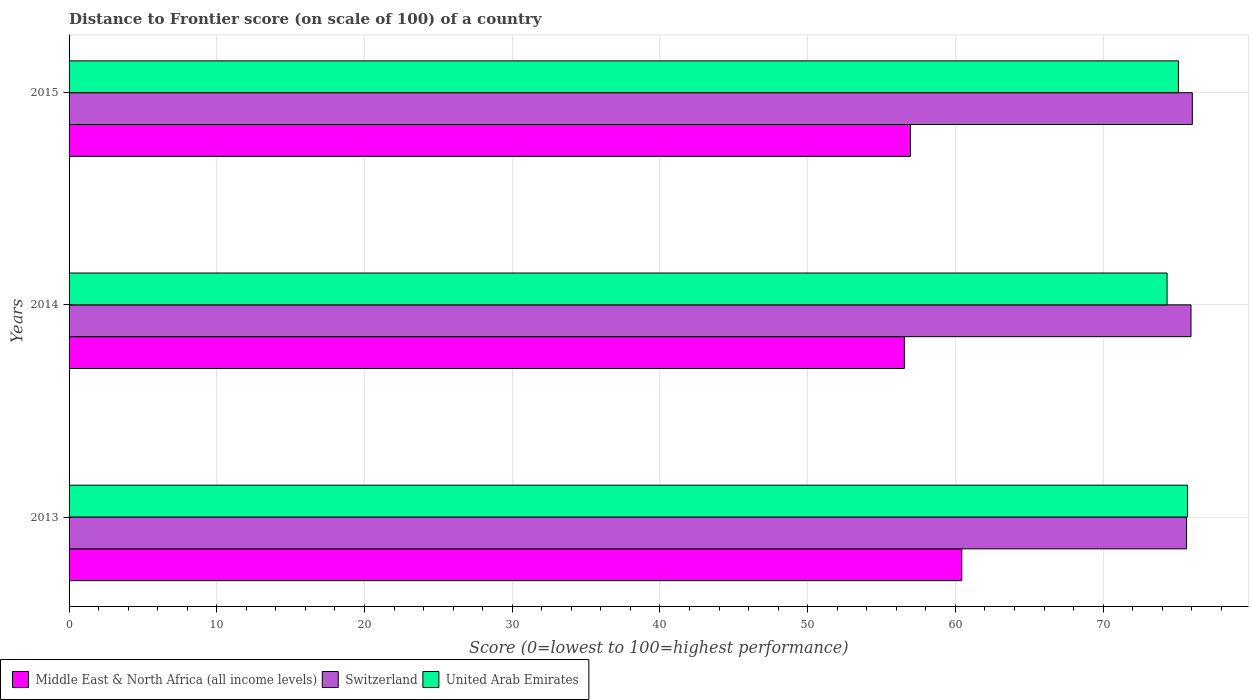How many bars are there on the 3rd tick from the bottom?
Offer a very short reply. 3. In how many cases, is the number of bars for a given year not equal to the number of legend labels?
Your answer should be very brief. 0. What is the distance to frontier score of in Middle East & North Africa (all income levels) in 2013?
Your response must be concise. 60.43. Across all years, what is the maximum distance to frontier score of in Middle East & North Africa (all income levels)?
Your answer should be compact. 60.43. Across all years, what is the minimum distance to frontier score of in United Arab Emirates?
Keep it short and to the point. 74.33. In which year was the distance to frontier score of in United Arab Emirates minimum?
Keep it short and to the point. 2014. What is the total distance to frontier score of in Middle East & North Africa (all income levels) in the graph?
Make the answer very short. 173.94. What is the difference between the distance to frontier score of in Middle East & North Africa (all income levels) in 2013 and that in 2014?
Your answer should be very brief. 3.89. What is the difference between the distance to frontier score of in United Arab Emirates in 2014 and the distance to frontier score of in Switzerland in 2015?
Offer a very short reply. -1.71. What is the average distance to frontier score of in Switzerland per year?
Offer a terse response. 75.88. In the year 2013, what is the difference between the distance to frontier score of in Middle East & North Africa (all income levels) and distance to frontier score of in Switzerland?
Offer a very short reply. -15.22. What is the ratio of the distance to frontier score of in United Arab Emirates in 2013 to that in 2015?
Your answer should be very brief. 1.01. Is the difference between the distance to frontier score of in Middle East & North Africa (all income levels) in 2013 and 2014 greater than the difference between the distance to frontier score of in Switzerland in 2013 and 2014?
Your response must be concise. Yes. What is the difference between the highest and the second highest distance to frontier score of in United Arab Emirates?
Your answer should be very brief. 0.61. What is the difference between the highest and the lowest distance to frontier score of in United Arab Emirates?
Offer a terse response. 1.38. What does the 3rd bar from the top in 2015 represents?
Ensure brevity in your answer.  Middle East & North Africa (all income levels). What does the 3rd bar from the bottom in 2014 represents?
Offer a terse response. United Arab Emirates. Is it the case that in every year, the sum of the distance to frontier score of in Middle East & North Africa (all income levels) and distance to frontier score of in Switzerland is greater than the distance to frontier score of in United Arab Emirates?
Provide a short and direct response. Yes. How many bars are there?
Keep it short and to the point. 9. Are all the bars in the graph horizontal?
Keep it short and to the point. Yes. How many years are there in the graph?
Offer a terse response. 3. Are the values on the major ticks of X-axis written in scientific E-notation?
Offer a very short reply. No. Where does the legend appear in the graph?
Your response must be concise. Bottom left. What is the title of the graph?
Provide a short and direct response. Distance to Frontier score (on scale of 100) of a country. Does "Bahrain" appear as one of the legend labels in the graph?
Ensure brevity in your answer.  No. What is the label or title of the X-axis?
Ensure brevity in your answer.  Score (0=lowest to 100=highest performance). What is the label or title of the Y-axis?
Your answer should be very brief. Years. What is the Score (0=lowest to 100=highest performance) in Middle East & North Africa (all income levels) in 2013?
Provide a short and direct response. 60.43. What is the Score (0=lowest to 100=highest performance) in Switzerland in 2013?
Provide a short and direct response. 75.65. What is the Score (0=lowest to 100=highest performance) in United Arab Emirates in 2013?
Give a very brief answer. 75.71. What is the Score (0=lowest to 100=highest performance) in Middle East & North Africa (all income levels) in 2014?
Your answer should be compact. 56.54. What is the Score (0=lowest to 100=highest performance) of Switzerland in 2014?
Keep it short and to the point. 75.95. What is the Score (0=lowest to 100=highest performance) of United Arab Emirates in 2014?
Offer a very short reply. 74.33. What is the Score (0=lowest to 100=highest performance) of Middle East & North Africa (all income levels) in 2015?
Ensure brevity in your answer.  56.96. What is the Score (0=lowest to 100=highest performance) in Switzerland in 2015?
Keep it short and to the point. 76.04. What is the Score (0=lowest to 100=highest performance) in United Arab Emirates in 2015?
Give a very brief answer. 75.1. Across all years, what is the maximum Score (0=lowest to 100=highest performance) in Middle East & North Africa (all income levels)?
Your answer should be compact. 60.43. Across all years, what is the maximum Score (0=lowest to 100=highest performance) of Switzerland?
Provide a succinct answer. 76.04. Across all years, what is the maximum Score (0=lowest to 100=highest performance) in United Arab Emirates?
Provide a succinct answer. 75.71. Across all years, what is the minimum Score (0=lowest to 100=highest performance) of Middle East & North Africa (all income levels)?
Provide a succinct answer. 56.54. Across all years, what is the minimum Score (0=lowest to 100=highest performance) of Switzerland?
Keep it short and to the point. 75.65. Across all years, what is the minimum Score (0=lowest to 100=highest performance) of United Arab Emirates?
Offer a very short reply. 74.33. What is the total Score (0=lowest to 100=highest performance) in Middle East & North Africa (all income levels) in the graph?
Make the answer very short. 173.94. What is the total Score (0=lowest to 100=highest performance) of Switzerland in the graph?
Your response must be concise. 227.64. What is the total Score (0=lowest to 100=highest performance) of United Arab Emirates in the graph?
Ensure brevity in your answer.  225.14. What is the difference between the Score (0=lowest to 100=highest performance) of Middle East & North Africa (all income levels) in 2013 and that in 2014?
Give a very brief answer. 3.89. What is the difference between the Score (0=lowest to 100=highest performance) of Switzerland in 2013 and that in 2014?
Your answer should be compact. -0.3. What is the difference between the Score (0=lowest to 100=highest performance) of United Arab Emirates in 2013 and that in 2014?
Your answer should be very brief. 1.38. What is the difference between the Score (0=lowest to 100=highest performance) in Middle East & North Africa (all income levels) in 2013 and that in 2015?
Offer a terse response. 3.48. What is the difference between the Score (0=lowest to 100=highest performance) of Switzerland in 2013 and that in 2015?
Your answer should be very brief. -0.39. What is the difference between the Score (0=lowest to 100=highest performance) of United Arab Emirates in 2013 and that in 2015?
Keep it short and to the point. 0.61. What is the difference between the Score (0=lowest to 100=highest performance) in Middle East & North Africa (all income levels) in 2014 and that in 2015?
Provide a succinct answer. -0.41. What is the difference between the Score (0=lowest to 100=highest performance) in Switzerland in 2014 and that in 2015?
Ensure brevity in your answer.  -0.09. What is the difference between the Score (0=lowest to 100=highest performance) in United Arab Emirates in 2014 and that in 2015?
Make the answer very short. -0.77. What is the difference between the Score (0=lowest to 100=highest performance) in Middle East & North Africa (all income levels) in 2013 and the Score (0=lowest to 100=highest performance) in Switzerland in 2014?
Make the answer very short. -15.52. What is the difference between the Score (0=lowest to 100=highest performance) in Middle East & North Africa (all income levels) in 2013 and the Score (0=lowest to 100=highest performance) in United Arab Emirates in 2014?
Provide a succinct answer. -13.9. What is the difference between the Score (0=lowest to 100=highest performance) of Switzerland in 2013 and the Score (0=lowest to 100=highest performance) of United Arab Emirates in 2014?
Provide a succinct answer. 1.32. What is the difference between the Score (0=lowest to 100=highest performance) of Middle East & North Africa (all income levels) in 2013 and the Score (0=lowest to 100=highest performance) of Switzerland in 2015?
Offer a very short reply. -15.61. What is the difference between the Score (0=lowest to 100=highest performance) of Middle East & North Africa (all income levels) in 2013 and the Score (0=lowest to 100=highest performance) of United Arab Emirates in 2015?
Offer a very short reply. -14.67. What is the difference between the Score (0=lowest to 100=highest performance) of Switzerland in 2013 and the Score (0=lowest to 100=highest performance) of United Arab Emirates in 2015?
Your response must be concise. 0.55. What is the difference between the Score (0=lowest to 100=highest performance) of Middle East & North Africa (all income levels) in 2014 and the Score (0=lowest to 100=highest performance) of Switzerland in 2015?
Provide a succinct answer. -19.5. What is the difference between the Score (0=lowest to 100=highest performance) of Middle East & North Africa (all income levels) in 2014 and the Score (0=lowest to 100=highest performance) of United Arab Emirates in 2015?
Provide a succinct answer. -18.56. What is the average Score (0=lowest to 100=highest performance) in Middle East & North Africa (all income levels) per year?
Your answer should be compact. 57.98. What is the average Score (0=lowest to 100=highest performance) of Switzerland per year?
Make the answer very short. 75.88. What is the average Score (0=lowest to 100=highest performance) of United Arab Emirates per year?
Ensure brevity in your answer.  75.05. In the year 2013, what is the difference between the Score (0=lowest to 100=highest performance) of Middle East & North Africa (all income levels) and Score (0=lowest to 100=highest performance) of Switzerland?
Your response must be concise. -15.22. In the year 2013, what is the difference between the Score (0=lowest to 100=highest performance) of Middle East & North Africa (all income levels) and Score (0=lowest to 100=highest performance) of United Arab Emirates?
Offer a terse response. -15.28. In the year 2013, what is the difference between the Score (0=lowest to 100=highest performance) of Switzerland and Score (0=lowest to 100=highest performance) of United Arab Emirates?
Offer a very short reply. -0.06. In the year 2014, what is the difference between the Score (0=lowest to 100=highest performance) in Middle East & North Africa (all income levels) and Score (0=lowest to 100=highest performance) in Switzerland?
Provide a short and direct response. -19.41. In the year 2014, what is the difference between the Score (0=lowest to 100=highest performance) of Middle East & North Africa (all income levels) and Score (0=lowest to 100=highest performance) of United Arab Emirates?
Your answer should be compact. -17.79. In the year 2014, what is the difference between the Score (0=lowest to 100=highest performance) of Switzerland and Score (0=lowest to 100=highest performance) of United Arab Emirates?
Ensure brevity in your answer.  1.62. In the year 2015, what is the difference between the Score (0=lowest to 100=highest performance) in Middle East & North Africa (all income levels) and Score (0=lowest to 100=highest performance) in Switzerland?
Ensure brevity in your answer.  -19.08. In the year 2015, what is the difference between the Score (0=lowest to 100=highest performance) in Middle East & North Africa (all income levels) and Score (0=lowest to 100=highest performance) in United Arab Emirates?
Offer a very short reply. -18.14. What is the ratio of the Score (0=lowest to 100=highest performance) in Middle East & North Africa (all income levels) in 2013 to that in 2014?
Provide a succinct answer. 1.07. What is the ratio of the Score (0=lowest to 100=highest performance) of United Arab Emirates in 2013 to that in 2014?
Make the answer very short. 1.02. What is the ratio of the Score (0=lowest to 100=highest performance) in Middle East & North Africa (all income levels) in 2013 to that in 2015?
Make the answer very short. 1.06. What is the ratio of the Score (0=lowest to 100=highest performance) of Switzerland in 2014 to that in 2015?
Your answer should be very brief. 1. What is the ratio of the Score (0=lowest to 100=highest performance) of United Arab Emirates in 2014 to that in 2015?
Provide a succinct answer. 0.99. What is the difference between the highest and the second highest Score (0=lowest to 100=highest performance) in Middle East & North Africa (all income levels)?
Offer a very short reply. 3.48. What is the difference between the highest and the second highest Score (0=lowest to 100=highest performance) of Switzerland?
Your answer should be very brief. 0.09. What is the difference between the highest and the second highest Score (0=lowest to 100=highest performance) of United Arab Emirates?
Make the answer very short. 0.61. What is the difference between the highest and the lowest Score (0=lowest to 100=highest performance) in Middle East & North Africa (all income levels)?
Give a very brief answer. 3.89. What is the difference between the highest and the lowest Score (0=lowest to 100=highest performance) in Switzerland?
Your answer should be very brief. 0.39. What is the difference between the highest and the lowest Score (0=lowest to 100=highest performance) in United Arab Emirates?
Make the answer very short. 1.38. 